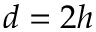<formula> <loc_0><loc_0><loc_500><loc_500>d = 2 h</formula> 